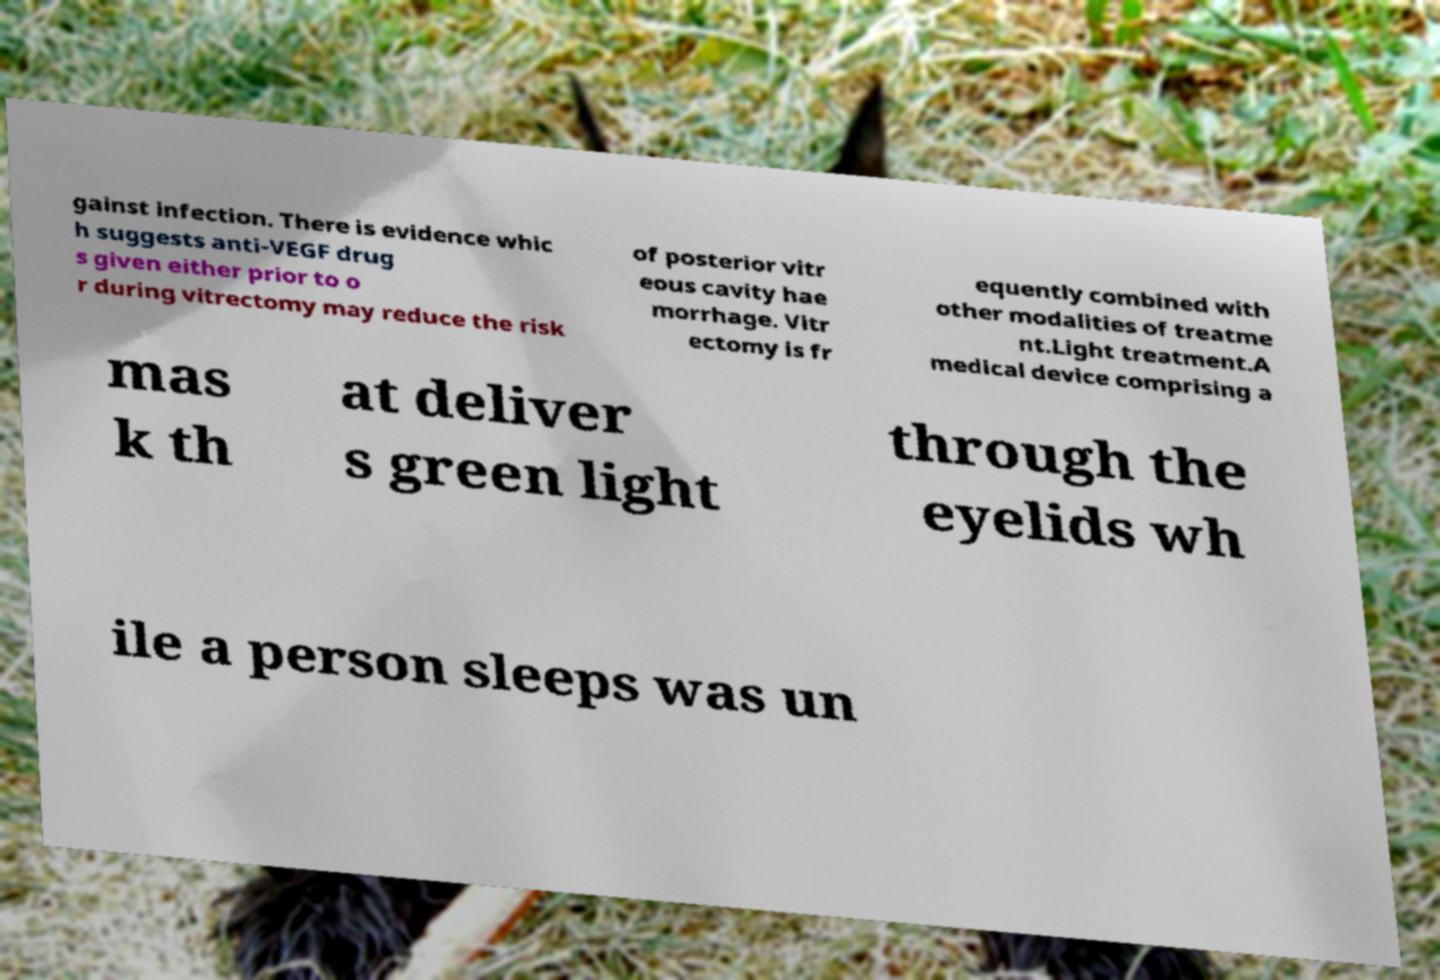Could you assist in decoding the text presented in this image and type it out clearly? gainst infection. There is evidence whic h suggests anti-VEGF drug s given either prior to o r during vitrectomy may reduce the risk of posterior vitr eous cavity hae morrhage. Vitr ectomy is fr equently combined with other modalities of treatme nt.Light treatment.A medical device comprising a mas k th at deliver s green light through the eyelids wh ile a person sleeps was un 